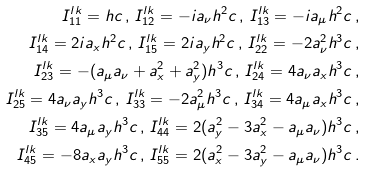<formula> <loc_0><loc_0><loc_500><loc_500>I _ { 1 1 } ^ { l k } = h c \, , \, I _ { 1 2 } ^ { l k } = - i a _ { \nu } h ^ { 2 } c \, , \, I _ { 1 3 } ^ { l k } = - i a _ { \mu } h ^ { 2 } c \, , \\ I _ { 1 4 } ^ { l k } = 2 i a _ { x } h ^ { 2 } c \, , \, I _ { 1 5 } ^ { l k } = 2 i a _ { y } h ^ { 2 } c \, , \, I _ { 2 2 } ^ { l k } = - 2 a _ { \nu } ^ { 2 } h ^ { 3 } c \, , \\ I _ { 2 3 } ^ { l k } = - ( a _ { \mu } a _ { \nu } + a _ { x } ^ { 2 } + a _ { y } ^ { 2 } ) h ^ { 3 } c \, , \, I _ { 2 4 } ^ { l k } = 4 a _ { \nu } a _ { x } h ^ { 3 } c \, , \\ I _ { 2 5 } ^ { l k } = 4 a _ { \nu } a _ { y } h ^ { 3 } c \, , \, I _ { 3 3 } ^ { l k } = - 2 a _ { \mu } ^ { 2 } h ^ { 3 } c \, , \, I _ { 3 4 } ^ { l k } = 4 a _ { \mu } a _ { x } h ^ { 3 } c \, , \\ I _ { 3 5 } ^ { l k } = 4 a _ { \mu } a _ { y } h ^ { 3 } c \, , \, I _ { 4 4 } ^ { l k } = 2 ( a _ { y } ^ { 2 } - 3 a _ { x } ^ { 2 } - a _ { \mu } a _ { \nu } ) h ^ { 3 } c \, , \\ I _ { 4 5 } ^ { l k } = - 8 a _ { x } a _ { y } h ^ { 3 } c \, , \, I _ { 5 5 } ^ { l k } = 2 ( a _ { x } ^ { 2 } - 3 a _ { y } ^ { 2 } - a _ { \mu } a _ { \nu } ) h ^ { 3 } c \, .</formula> 